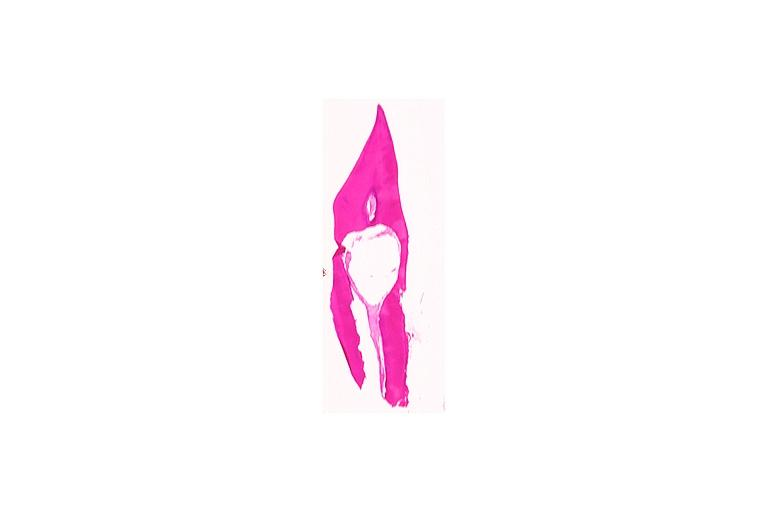what does this image show?
Answer the question using a single word or phrase. Internal resorption 